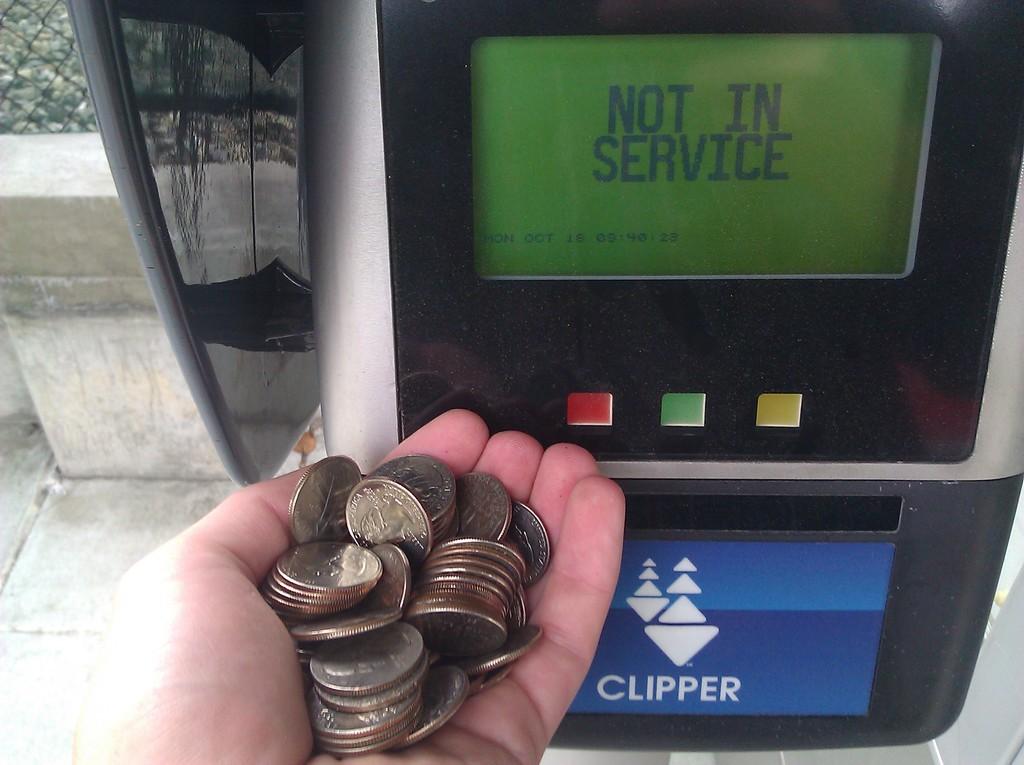Is the machine in service?
Your answer should be compact. No. What is written on the blue sticker below the display?
Keep it short and to the point. Clipper. 